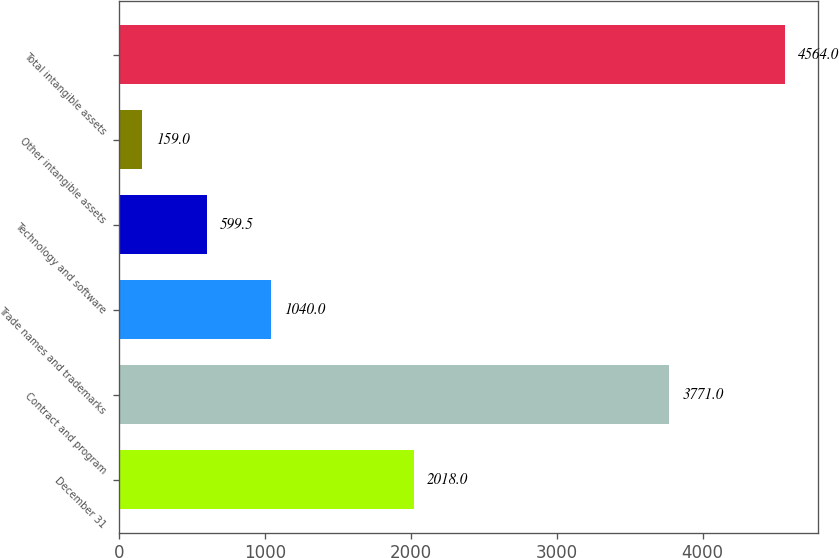<chart> <loc_0><loc_0><loc_500><loc_500><bar_chart><fcel>December 31<fcel>Contract and program<fcel>Trade names and trademarks<fcel>Technology and software<fcel>Other intangible assets<fcel>Total intangible assets<nl><fcel>2018<fcel>3771<fcel>1040<fcel>599.5<fcel>159<fcel>4564<nl></chart> 